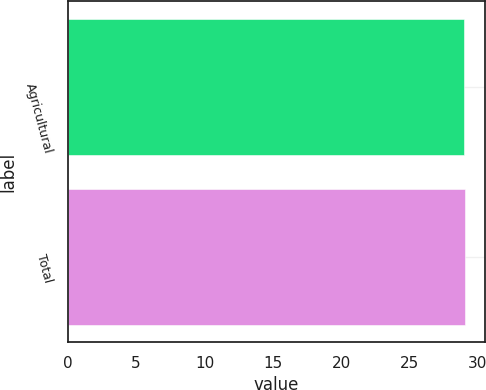Convert chart to OTSL. <chart><loc_0><loc_0><loc_500><loc_500><bar_chart><fcel>Agricultural<fcel>Total<nl><fcel>29<fcel>29.1<nl></chart> 